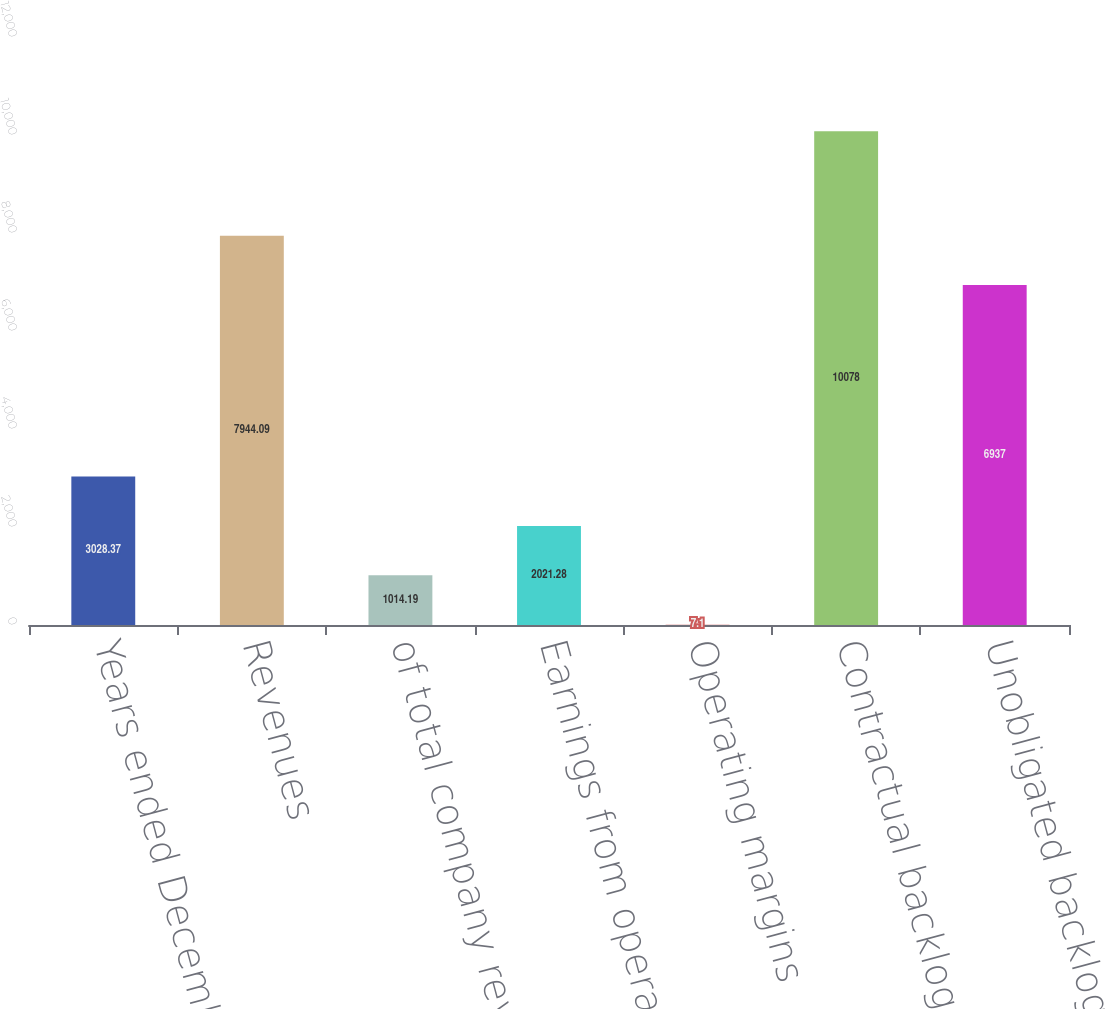Convert chart. <chart><loc_0><loc_0><loc_500><loc_500><bar_chart><fcel>Years ended December 31<fcel>Revenues<fcel>of total company revenues<fcel>Earnings from operations<fcel>Operating margins<fcel>Contractual backlog<fcel>Unobligated backlog<nl><fcel>3028.37<fcel>7944.09<fcel>1014.19<fcel>2021.28<fcel>7.1<fcel>10078<fcel>6937<nl></chart> 